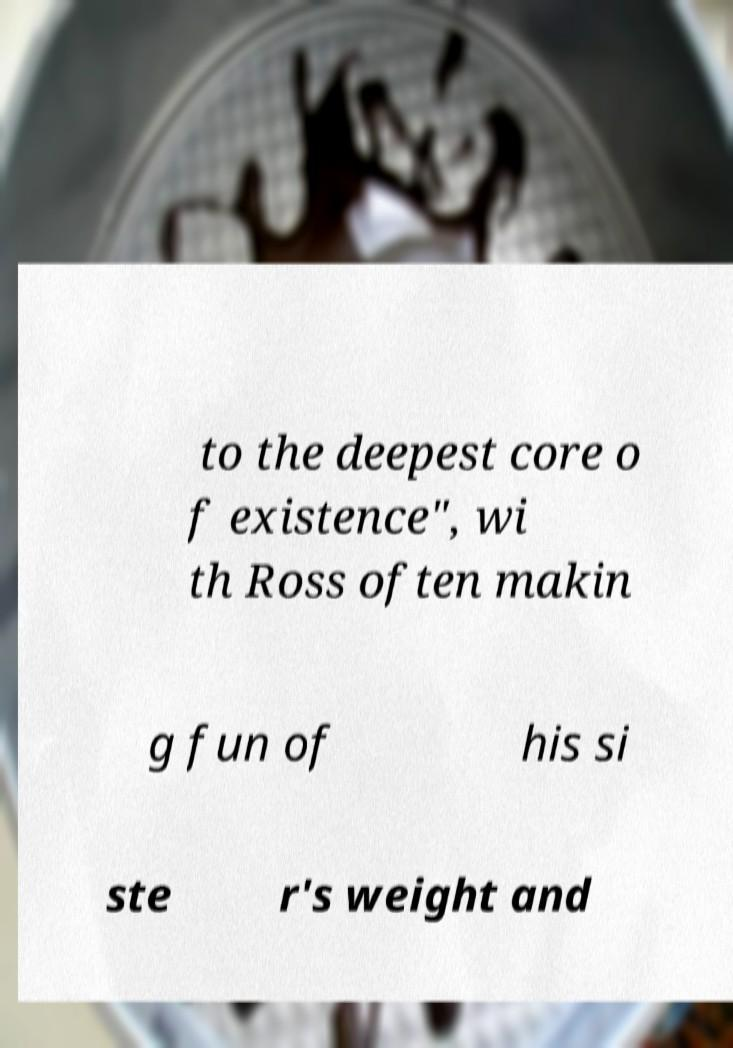I need the written content from this picture converted into text. Can you do that? to the deepest core o f existence", wi th Ross often makin g fun of his si ste r's weight and 